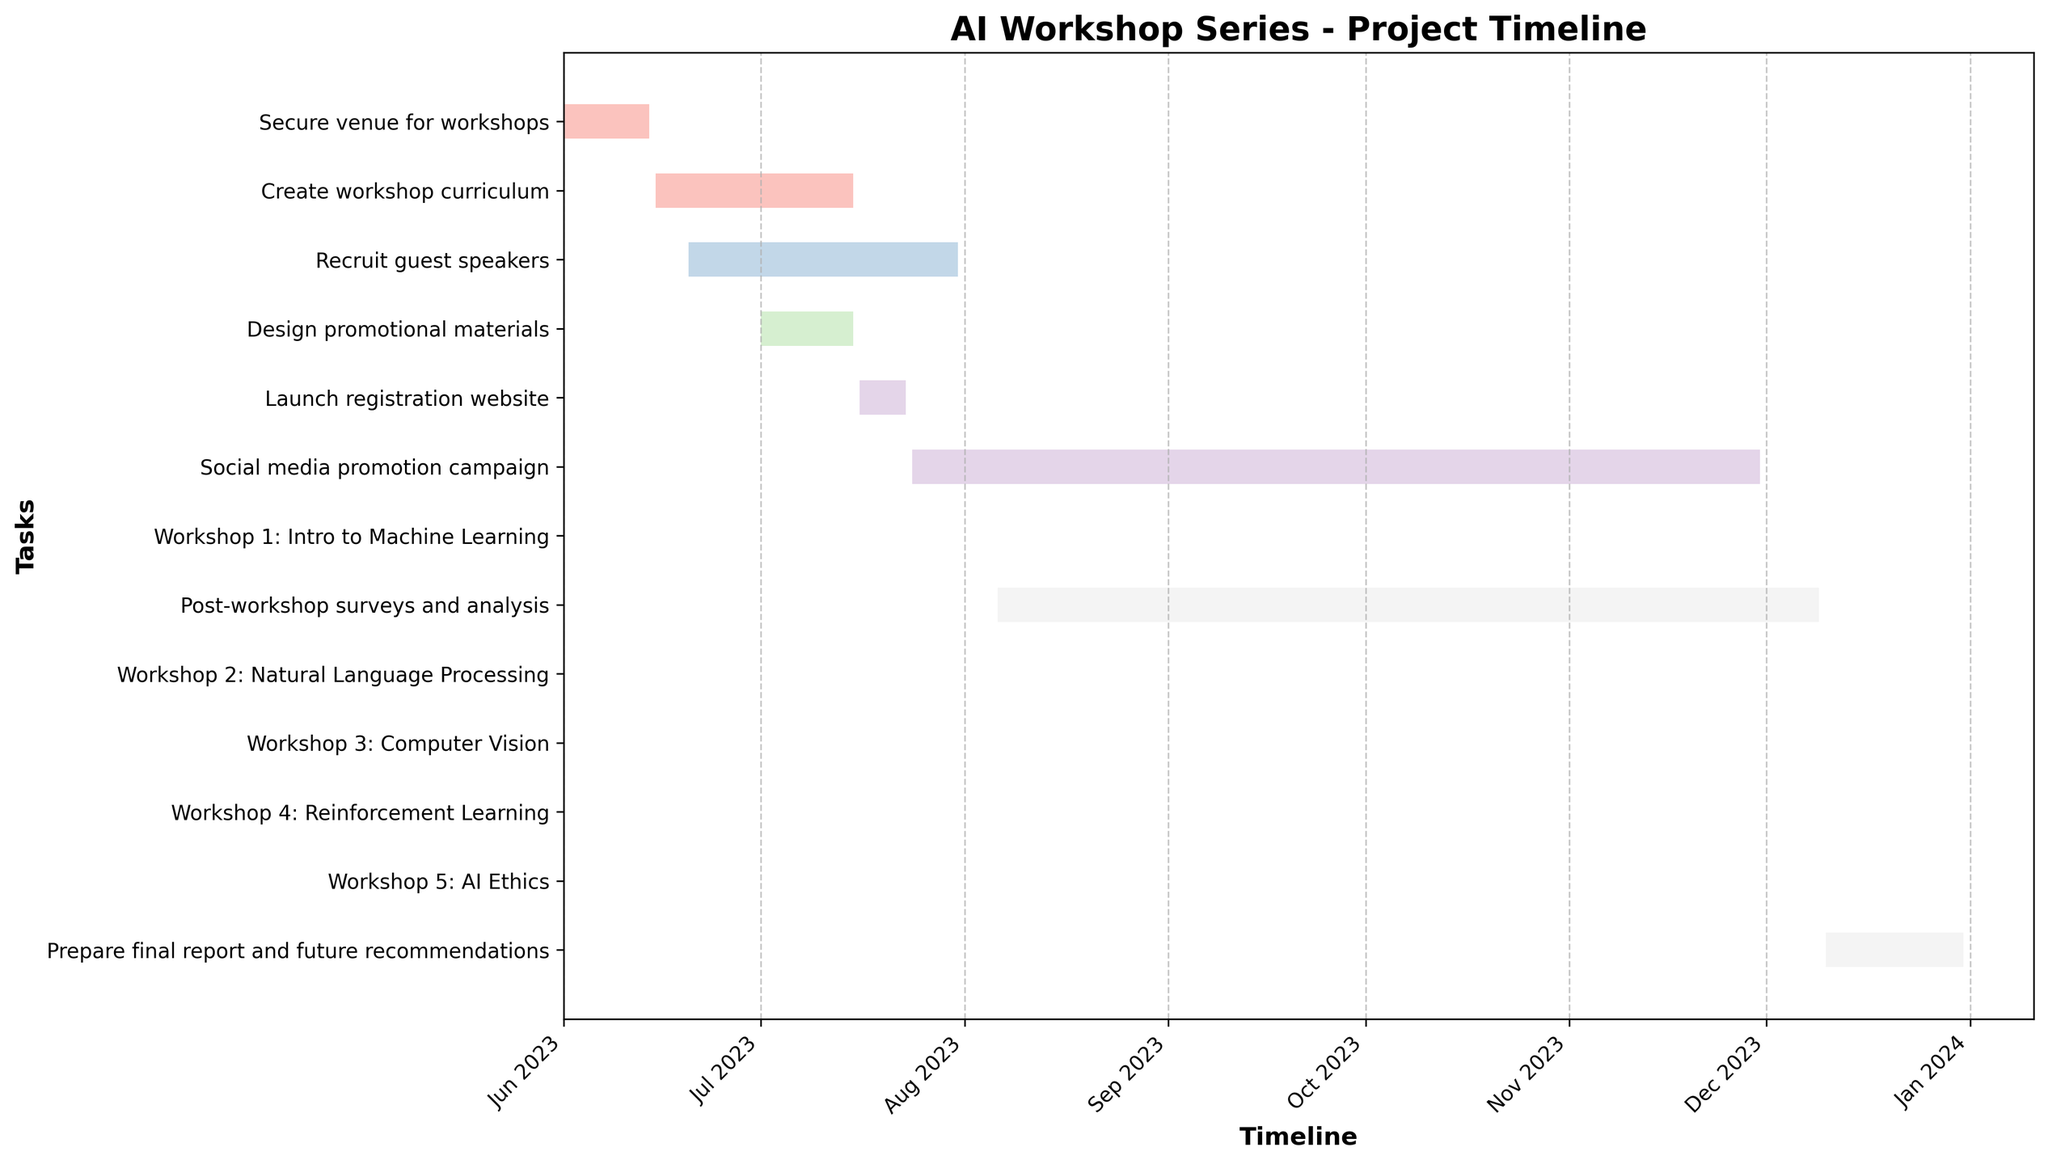What's the title of the Gantt chart? The title of the Gantt chart is usually placed at the top of the figure. By observing the plot, the title can be easily identified.
Answer: AI Workshop Series - Project Timeline How long is the "Secure venue for workshops" task? The task duration is represented by the length of the bar on the Gantt chart. The start date is 2023-06-01 and the end date is 2023-06-14, giving a duration of 14 days.
Answer: 14 days Which task has the longest duration? To determine the longest task, compare the lengths of all bars. "Social media promotion campaign" is the longest, spanning from 2023-07-24 to 2023-11-30, covering 130 days.
Answer: Social media promotion campaign What is the total duration from "Create workshop curriculum" to "Design promotional materials"? Calculate the total duration by summing the individual durations: "Create workshop curriculum" (31 days) and "Design promotional materials" (15 days). 31 + 15 = 46 days.
Answer: 46 days Which workshop occurs first, and on what date? Locate the bar corresponding to workshops and identify the one starting earlier, which is "Workshop 1: Intro to Machine Learning" occurring on 2023-08-05.
Answer: Workshop 1: Intro to Machine Learning, 2023-08-05 Does any task overlap with "Launch registration website"? Check if any other tasks' bars overlap with "Launch registration website" (2023-07-16 to 2023-07-23). "Design promotional materials" and "Social media promotion campaign" both overlap.
Answer: Yes What is the time gap between the end of "Recruit guest speakers" and the start of "Workshop 1: Intro to Machine Learning"? Identify the end date of "Recruit guest speakers" (2023-07-31) and the start date of the first workshop (2023-08-05). The gap is 5 days.
Answer: 5 days Which tasks are still ongoing after "Workshop 3: Computer Vision"? Find tasks starting after "Workshop 3: Computer Vision" ends on 2023-10-07. The ones ongoing are "Workshop 4: Reinforcement Learning," "Workshop 5: AI Ethics," "Social media promotion campaign," and "Post-workshop surveys and analysis."
Answer: Workshop 4: Reinforcement Learning, Workshop 5: AI Ethics, Social Media Promotion Campaign, Post-workshop surveys and analysis How long is the "Post-workshop surveys and analysis" task in comparison with the "Social media promotion campaign"? Measure the durations of both tasks. "Post-workshop surveys and analysis" is 126 days and "Social media promotion campaign" is 130 days. The former is 4 days shorter.
Answer: 4 days shorter Does "Prepare final report and future recommendations" overlap with "Workshop 5: AI Ethics"? Check the dates: "Prepare final report and future recommendations" spans from 2023-12-10 to 2023-12-31, whereas "Workshop 5: AI Ethics" is on 2023-12-02. There is no overlap.
Answer: No 